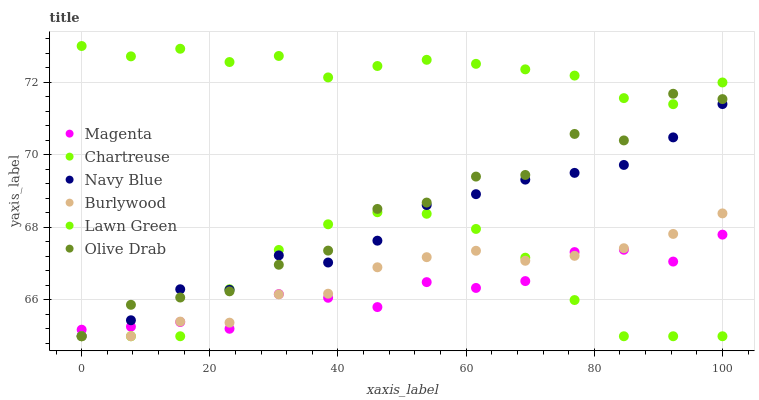Does Magenta have the minimum area under the curve?
Answer yes or no. Yes. Does Lawn Green have the maximum area under the curve?
Answer yes or no. Yes. Does Burlywood have the minimum area under the curve?
Answer yes or no. No. Does Burlywood have the maximum area under the curve?
Answer yes or no. No. Is Chartreuse the smoothest?
Answer yes or no. Yes. Is Olive Drab the roughest?
Answer yes or no. Yes. Is Burlywood the smoothest?
Answer yes or no. No. Is Burlywood the roughest?
Answer yes or no. No. Does Burlywood have the lowest value?
Answer yes or no. Yes. Does Navy Blue have the lowest value?
Answer yes or no. No. Does Lawn Green have the highest value?
Answer yes or no. Yes. Does Burlywood have the highest value?
Answer yes or no. No. Is Burlywood less than Lawn Green?
Answer yes or no. Yes. Is Lawn Green greater than Magenta?
Answer yes or no. Yes. Does Lawn Green intersect Olive Drab?
Answer yes or no. Yes. Is Lawn Green less than Olive Drab?
Answer yes or no. No. Is Lawn Green greater than Olive Drab?
Answer yes or no. No. Does Burlywood intersect Lawn Green?
Answer yes or no. No. 